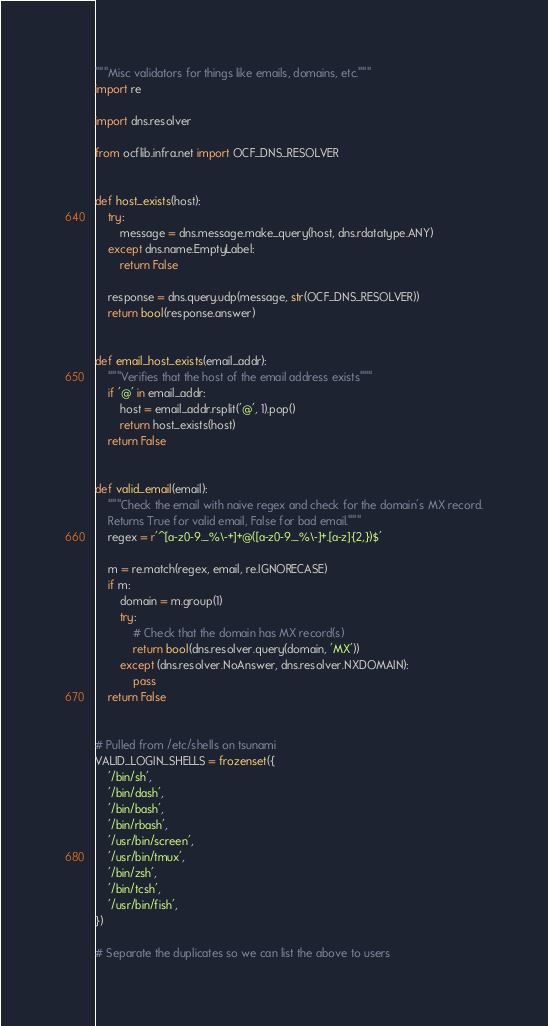<code> <loc_0><loc_0><loc_500><loc_500><_Python_>"""Misc validators for things like emails, domains, etc."""
import re

import dns.resolver

from ocflib.infra.net import OCF_DNS_RESOLVER


def host_exists(host):
    try:
        message = dns.message.make_query(host, dns.rdatatype.ANY)
    except dns.name.EmptyLabel:
        return False

    response = dns.query.udp(message, str(OCF_DNS_RESOLVER))
    return bool(response.answer)


def email_host_exists(email_addr):
    """Verifies that the host of the email address exists"""
    if '@' in email_addr:
        host = email_addr.rsplit('@', 1).pop()
        return host_exists(host)
    return False


def valid_email(email):
    """Check the email with naive regex and check for the domain's MX record.
    Returns True for valid email, False for bad email."""
    regex = r'^[a-z0-9._%\-+]+@([a-z0-9._%\-]+.[a-z]{2,})$'

    m = re.match(regex, email, re.IGNORECASE)
    if m:
        domain = m.group(1)
        try:
            # Check that the domain has MX record(s)
            return bool(dns.resolver.query(domain, 'MX'))
        except (dns.resolver.NoAnswer, dns.resolver.NXDOMAIN):
            pass
    return False


# Pulled from /etc/shells on tsunami
VALID_LOGIN_SHELLS = frozenset({
    '/bin/sh',
    '/bin/dash',
    '/bin/bash',
    '/bin/rbash',
    '/usr/bin/screen',
    '/usr/bin/tmux',
    '/bin/zsh',
    '/bin/tcsh',
    '/usr/bin/fish',
})

# Separate the duplicates so we can list the above to users</code> 